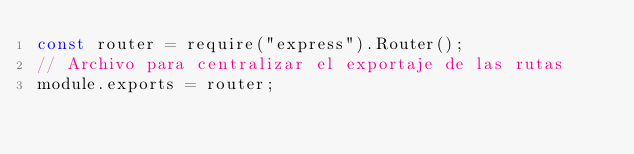Convert code to text. <code><loc_0><loc_0><loc_500><loc_500><_JavaScript_>const router = require("express").Router();
// Archivo para centralizar el exportaje de las rutas
module.exports = router;
</code> 